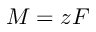Convert formula to latex. <formula><loc_0><loc_0><loc_500><loc_500>M = z F</formula> 